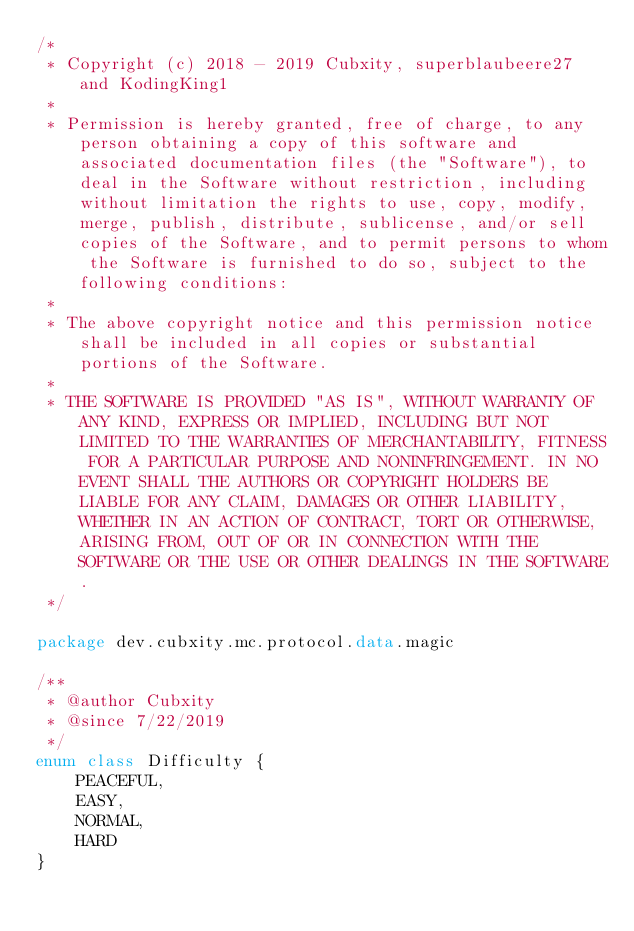<code> <loc_0><loc_0><loc_500><loc_500><_Kotlin_>/*
 * Copyright (c) 2018 - 2019 Cubxity, superblaubeere27 and KodingKing1
 *
 * Permission is hereby granted, free of charge, to any person obtaining a copy of this software and associated documentation files (the "Software"), to deal in the Software without restriction, including without limitation the rights to use, copy, modify, merge, publish, distribute, sublicense, and/or sell copies of the Software, and to permit persons to whom the Software is furnished to do so, subject to the following conditions:
 *
 * The above copyright notice and this permission notice shall be included in all copies or substantial portions of the Software.
 *
 * THE SOFTWARE IS PROVIDED "AS IS", WITHOUT WARRANTY OF ANY KIND, EXPRESS OR IMPLIED, INCLUDING BUT NOT LIMITED TO THE WARRANTIES OF MERCHANTABILITY, FITNESS FOR A PARTICULAR PURPOSE AND NONINFRINGEMENT. IN NO EVENT SHALL THE AUTHORS OR COPYRIGHT HOLDERS BE LIABLE FOR ANY CLAIM, DAMAGES OR OTHER LIABILITY, WHETHER IN AN ACTION OF CONTRACT, TORT OR OTHERWISE, ARISING FROM, OUT OF OR IN CONNECTION WITH THE SOFTWARE OR THE USE OR OTHER DEALINGS IN THE SOFTWARE.
 */

package dev.cubxity.mc.protocol.data.magic

/**
 * @author Cubxity
 * @since 7/22/2019
 */
enum class Difficulty {
    PEACEFUL,
    EASY,
    NORMAL,
    HARD
}</code> 